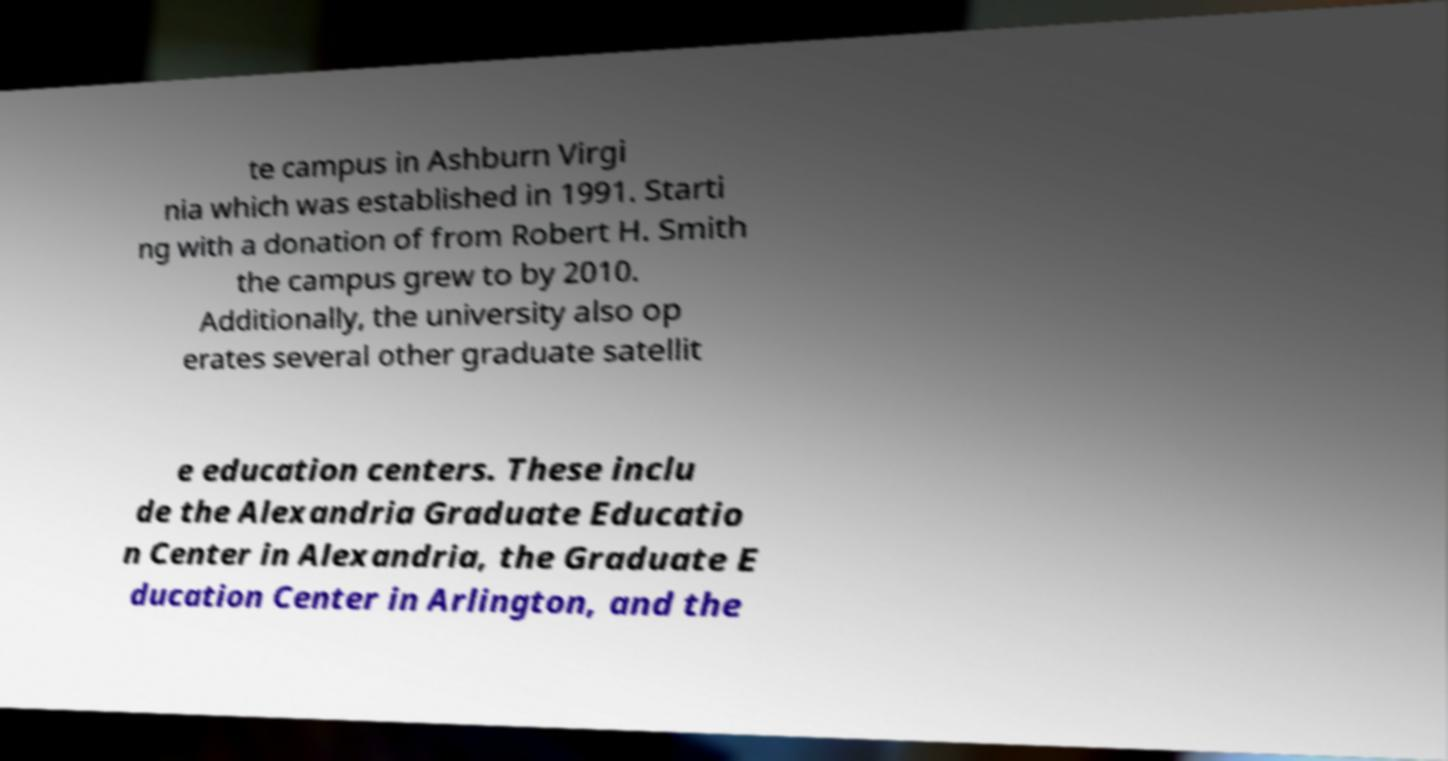Please identify and transcribe the text found in this image. te campus in Ashburn Virgi nia which was established in 1991. Starti ng with a donation of from Robert H. Smith the campus grew to by 2010. Additionally, the university also op erates several other graduate satellit e education centers. These inclu de the Alexandria Graduate Educatio n Center in Alexandria, the Graduate E ducation Center in Arlington, and the 